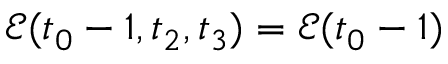<formula> <loc_0><loc_0><loc_500><loc_500>\mathcal { E } ( t _ { 0 } - 1 , t _ { 2 } , t _ { 3 } ) = \mathcal { E } ( t _ { 0 } - 1 )</formula> 